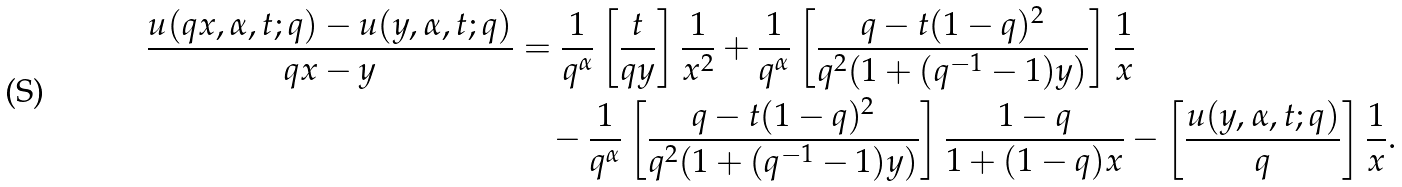<formula> <loc_0><loc_0><loc_500><loc_500>\frac { u ( q x , \alpha , t ; q ) - u ( y , \alpha , t ; q ) } { q x - y } & = \frac { 1 } { q ^ { \alpha } } \left [ \frac { t } { q y } \right ] \frac { 1 } { x ^ { 2 } } + \frac { 1 } { q ^ { \alpha } } \left [ \frac { q - t ( 1 - q ) ^ { 2 } } { q ^ { 2 } ( 1 + ( q ^ { - 1 } - 1 ) y ) } \right ] \frac { 1 } { x } \\ & \quad - \frac { 1 } { q ^ { \alpha } } \left [ \frac { q - t ( 1 - q ) ^ { 2 } } { q ^ { 2 } ( 1 + ( q ^ { - 1 } - 1 ) y ) } \right ] \frac { 1 - q } { 1 + ( 1 - q ) x } - \left [ \frac { u ( y , \alpha , t ; q ) } { q } \right ] \frac { 1 } { x } .</formula> 